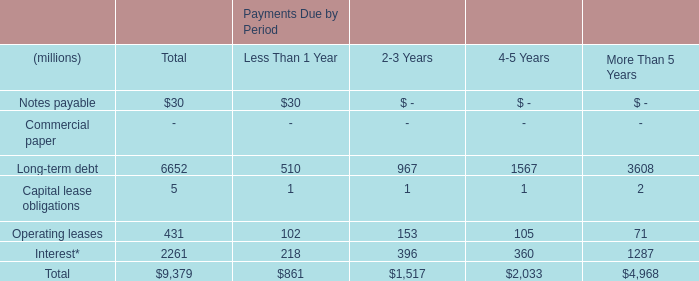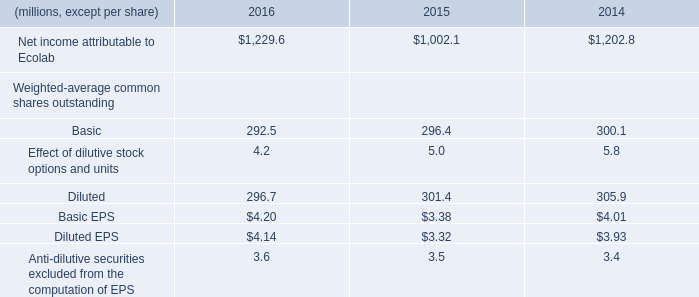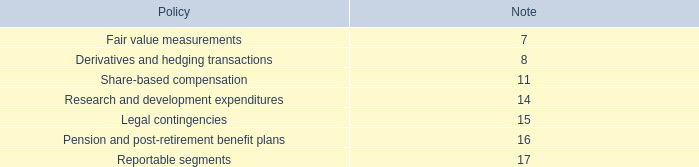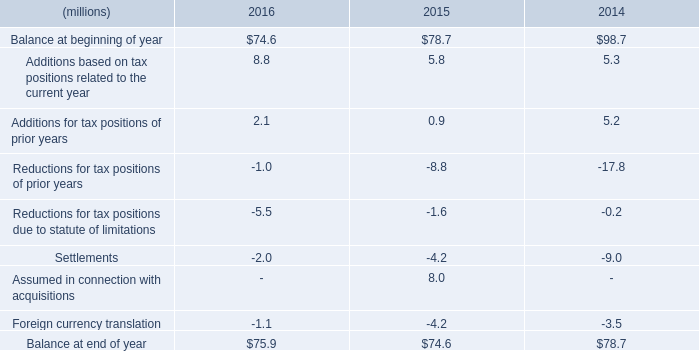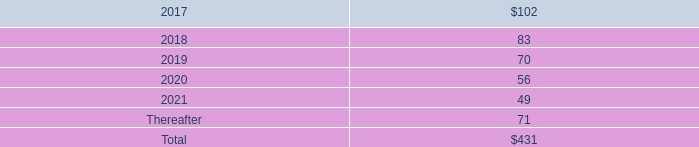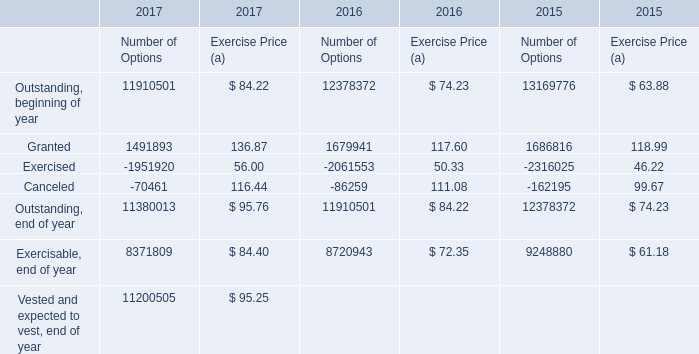What's the average of Canceled of 2017 Number of Options, and Interest* of Payments Due by Period More Than 5 Years ? 
Computations: ((70461.0 + 1287.0) / 2)
Answer: 35874.0. 